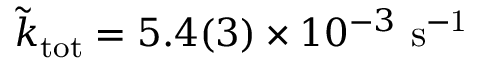<formula> <loc_0><loc_0><loc_500><loc_500>\tilde { k } _ { t o t } = 5 . 4 ( 3 ) \times 1 0 ^ { - 3 } s ^ { - 1 }</formula> 